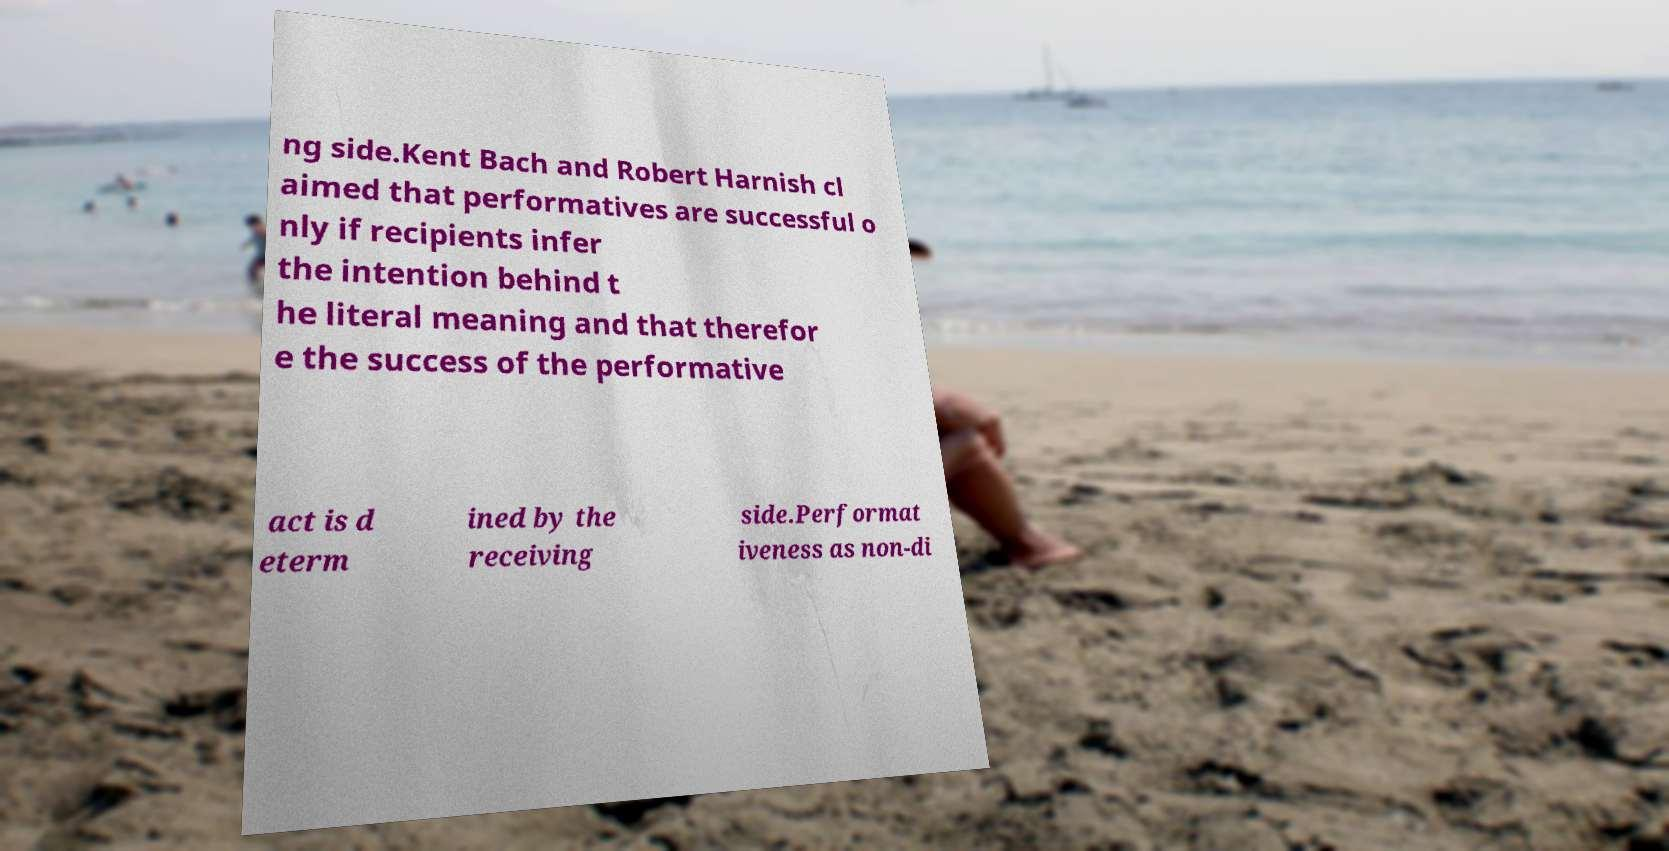Please identify and transcribe the text found in this image. ng side.Kent Bach and Robert Harnish cl aimed that performatives are successful o nly if recipients infer the intention behind t he literal meaning and that therefor e the success of the performative act is d eterm ined by the receiving side.Performat iveness as non-di 